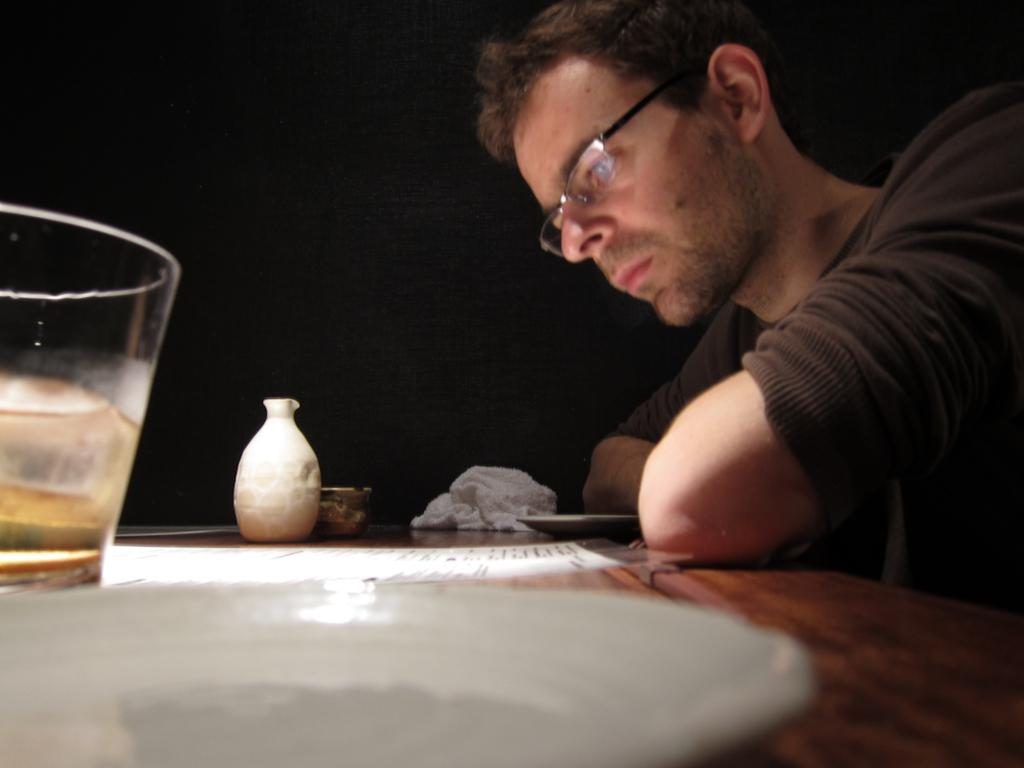Who is present in the image? There is a man in the image. What object can be seen in the image besides the man? There is a table in the image. What is on the table in the image? There is a glass on the table. What type of flesh can be seen on the man's face in the image? There is no flesh visible on the man's face in the image; it is a photograph or illustration, not a real person. 